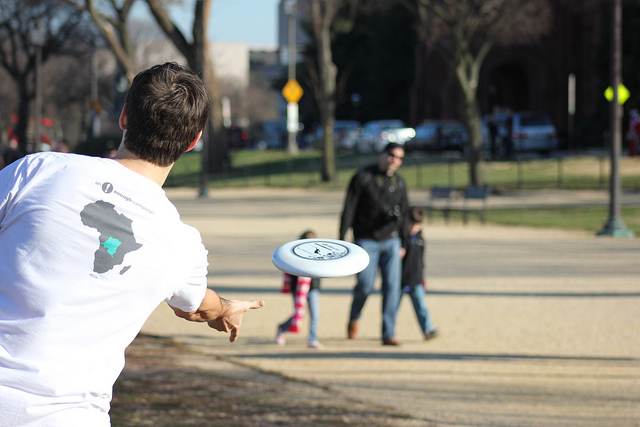Are there others present around the people playing with the frisbee? Aside from the two individuals engaged in the frisbee game, there's at least one other person visible in the background. This person appears to be a bystander observing the activity, and there's ample space around, hinting at a peaceful, uncrowded environment. 